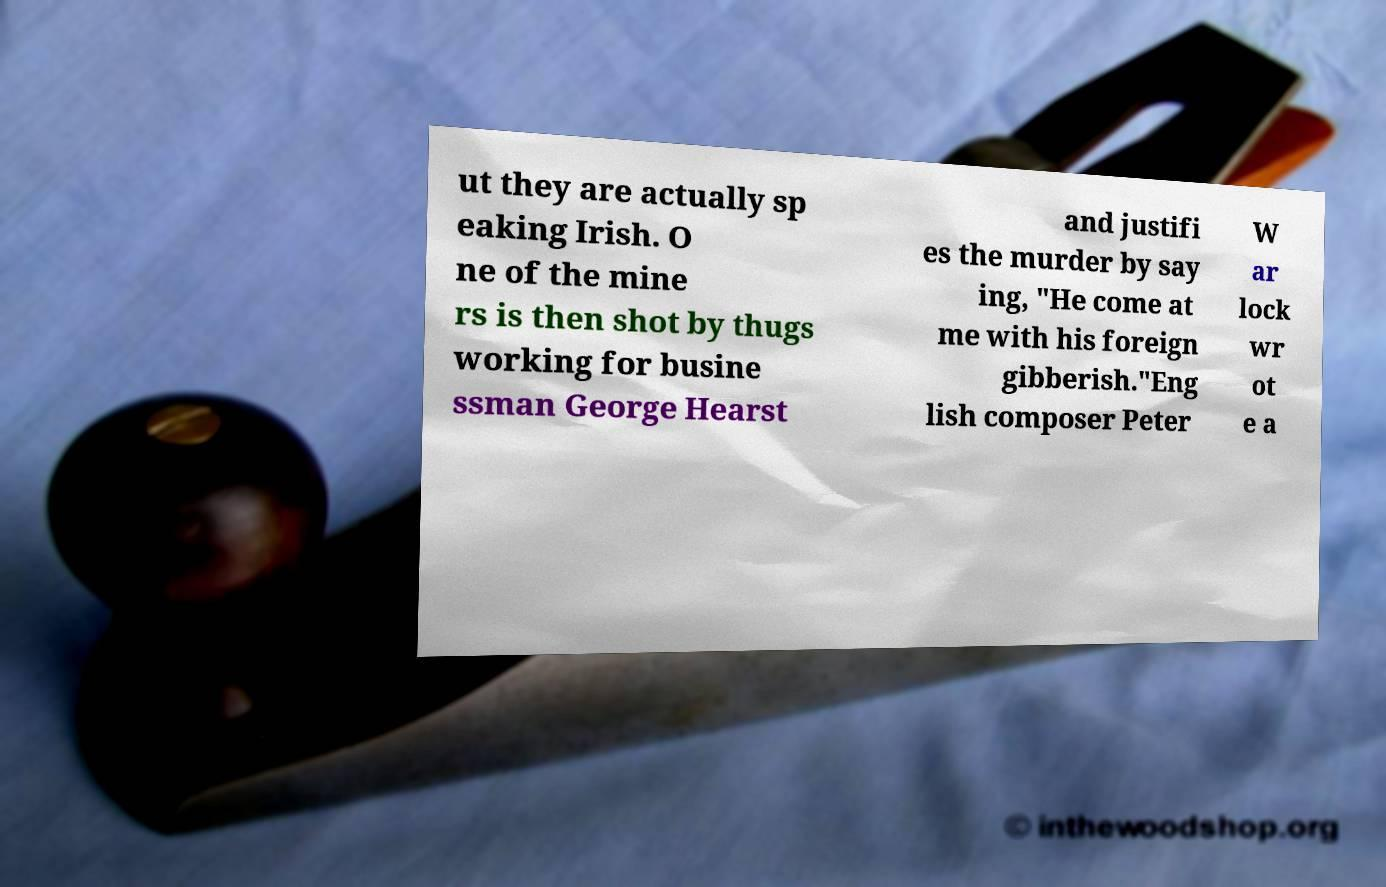Can you read and provide the text displayed in the image?This photo seems to have some interesting text. Can you extract and type it out for me? ut they are actually sp eaking Irish. O ne of the mine rs is then shot by thugs working for busine ssman George Hearst and justifi es the murder by say ing, "He come at me with his foreign gibberish."Eng lish composer Peter W ar lock wr ot e a 